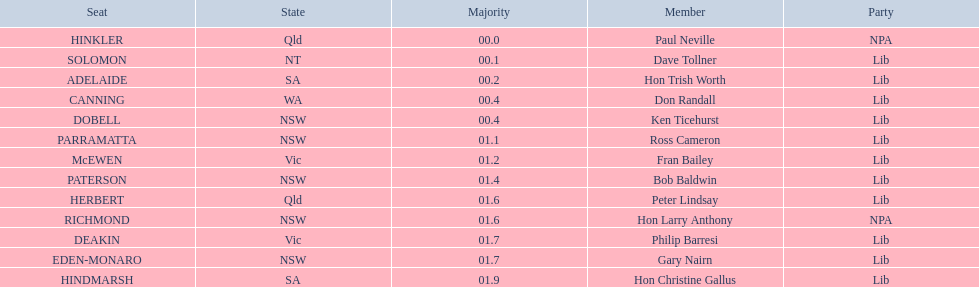Who are the entire lib party members? Dave Tollner, Hon Trish Worth, Don Randall, Ken Ticehurst, Ross Cameron, Fran Bailey, Bob Baldwin, Peter Lindsay, Philip Barresi, Gary Nairn, Hon Christine Gallus. Which lib party members are present in sa? Hon Trish Worth, Hon Christine Gallus. What is the maximum difference in majority between members in sa? 01.9. 